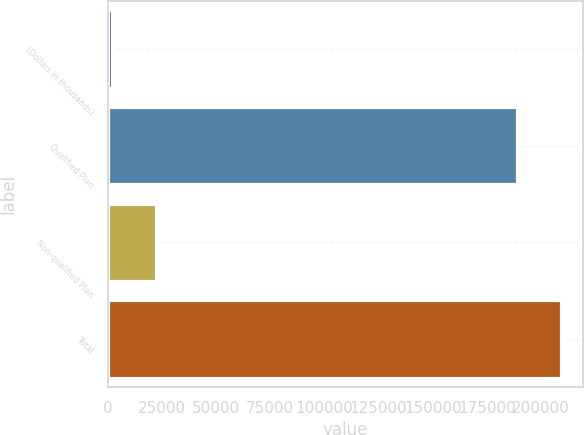<chart> <loc_0><loc_0><loc_500><loc_500><bar_chart><fcel>(Dollars in thousands)<fcel>Qualified Plan<fcel>Non-qualified Plan<fcel>Total<nl><fcel>2015<fcel>188702<fcel>22459.3<fcel>209146<nl></chart> 